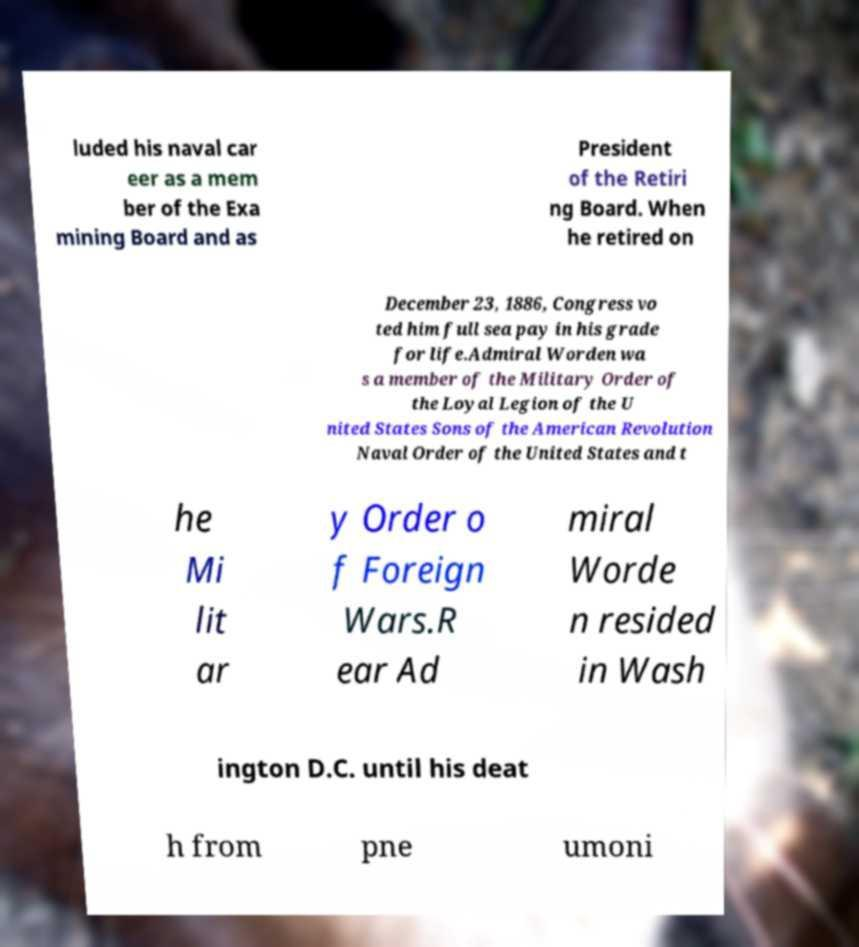Could you extract and type out the text from this image? luded his naval car eer as a mem ber of the Exa mining Board and as President of the Retiri ng Board. When he retired on December 23, 1886, Congress vo ted him full sea pay in his grade for life.Admiral Worden wa s a member of the Military Order of the Loyal Legion of the U nited States Sons of the American Revolution Naval Order of the United States and t he Mi lit ar y Order o f Foreign Wars.R ear Ad miral Worde n resided in Wash ington D.C. until his deat h from pne umoni 